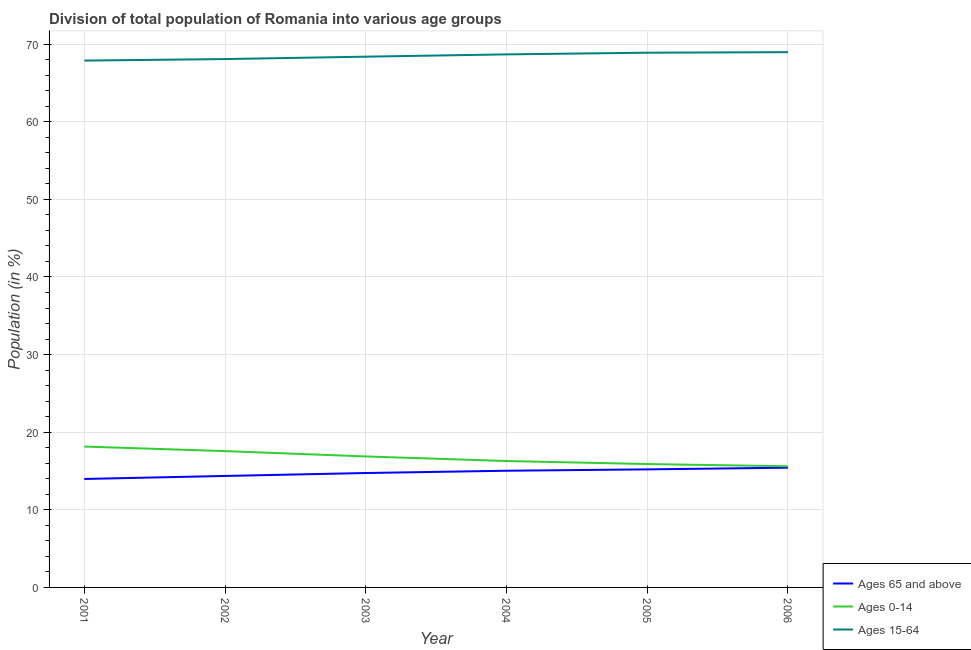Does the line corresponding to percentage of population within the age-group 15-64 intersect with the line corresponding to percentage of population within the age-group 0-14?
Provide a succinct answer. No. Is the number of lines equal to the number of legend labels?
Your answer should be compact. Yes. What is the percentage of population within the age-group of 65 and above in 2003?
Your answer should be very brief. 14.74. Across all years, what is the maximum percentage of population within the age-group 0-14?
Your answer should be compact. 18.15. Across all years, what is the minimum percentage of population within the age-group 0-14?
Your answer should be very brief. 15.61. In which year was the percentage of population within the age-group of 65 and above minimum?
Make the answer very short. 2001. What is the total percentage of population within the age-group 0-14 in the graph?
Keep it short and to the point. 100.38. What is the difference between the percentage of population within the age-group 0-14 in 2002 and that in 2006?
Ensure brevity in your answer.  1.95. What is the difference between the percentage of population within the age-group 0-14 in 2005 and the percentage of population within the age-group of 65 and above in 2001?
Keep it short and to the point. 1.92. What is the average percentage of population within the age-group 15-64 per year?
Give a very brief answer. 68.48. In the year 2003, what is the difference between the percentage of population within the age-group of 65 and above and percentage of population within the age-group 15-64?
Offer a terse response. -53.64. In how many years, is the percentage of population within the age-group 0-14 greater than 50 %?
Make the answer very short. 0. What is the ratio of the percentage of population within the age-group 15-64 in 2002 to that in 2006?
Your answer should be very brief. 0.99. Is the percentage of population within the age-group 15-64 in 2001 less than that in 2005?
Offer a terse response. Yes. What is the difference between the highest and the second highest percentage of population within the age-group of 65 and above?
Give a very brief answer. 0.22. What is the difference between the highest and the lowest percentage of population within the age-group of 65 and above?
Give a very brief answer. 1.45. Does the percentage of population within the age-group 0-14 monotonically increase over the years?
Offer a very short reply. No. Is the percentage of population within the age-group 15-64 strictly greater than the percentage of population within the age-group 0-14 over the years?
Give a very brief answer. Yes. Is the percentage of population within the age-group 0-14 strictly less than the percentage of population within the age-group of 65 and above over the years?
Your answer should be compact. No. How many years are there in the graph?
Ensure brevity in your answer.  6. Where does the legend appear in the graph?
Offer a terse response. Bottom right. How are the legend labels stacked?
Make the answer very short. Vertical. What is the title of the graph?
Keep it short and to the point. Division of total population of Romania into various age groups
. Does "Methane" appear as one of the legend labels in the graph?
Your answer should be compact. No. What is the label or title of the Y-axis?
Your answer should be very brief. Population (in %). What is the Population (in %) in Ages 65 and above in 2001?
Give a very brief answer. 13.97. What is the Population (in %) of Ages 0-14 in 2001?
Make the answer very short. 18.15. What is the Population (in %) of Ages 15-64 in 2001?
Provide a succinct answer. 67.88. What is the Population (in %) of Ages 65 and above in 2002?
Offer a very short reply. 14.36. What is the Population (in %) in Ages 0-14 in 2002?
Provide a succinct answer. 17.56. What is the Population (in %) of Ages 15-64 in 2002?
Make the answer very short. 68.07. What is the Population (in %) in Ages 65 and above in 2003?
Keep it short and to the point. 14.74. What is the Population (in %) in Ages 0-14 in 2003?
Provide a short and direct response. 16.88. What is the Population (in %) of Ages 15-64 in 2003?
Make the answer very short. 68.38. What is the Population (in %) in Ages 65 and above in 2004?
Offer a terse response. 15.03. What is the Population (in %) of Ages 0-14 in 2004?
Keep it short and to the point. 16.29. What is the Population (in %) of Ages 15-64 in 2004?
Make the answer very short. 68.68. What is the Population (in %) in Ages 65 and above in 2005?
Make the answer very short. 15.21. What is the Population (in %) of Ages 0-14 in 2005?
Provide a succinct answer. 15.9. What is the Population (in %) in Ages 15-64 in 2005?
Give a very brief answer. 68.89. What is the Population (in %) in Ages 65 and above in 2006?
Keep it short and to the point. 15.43. What is the Population (in %) in Ages 0-14 in 2006?
Your answer should be very brief. 15.61. What is the Population (in %) in Ages 15-64 in 2006?
Provide a succinct answer. 68.96. Across all years, what is the maximum Population (in %) of Ages 65 and above?
Give a very brief answer. 15.43. Across all years, what is the maximum Population (in %) of Ages 0-14?
Ensure brevity in your answer.  18.15. Across all years, what is the maximum Population (in %) of Ages 15-64?
Your answer should be compact. 68.96. Across all years, what is the minimum Population (in %) of Ages 65 and above?
Ensure brevity in your answer.  13.97. Across all years, what is the minimum Population (in %) in Ages 0-14?
Offer a terse response. 15.61. Across all years, what is the minimum Population (in %) in Ages 15-64?
Provide a short and direct response. 67.88. What is the total Population (in %) in Ages 65 and above in the graph?
Your response must be concise. 88.75. What is the total Population (in %) in Ages 0-14 in the graph?
Provide a succinct answer. 100.38. What is the total Population (in %) of Ages 15-64 in the graph?
Keep it short and to the point. 410.87. What is the difference between the Population (in %) in Ages 65 and above in 2001 and that in 2002?
Give a very brief answer. -0.39. What is the difference between the Population (in %) of Ages 0-14 in 2001 and that in 2002?
Your response must be concise. 0.59. What is the difference between the Population (in %) in Ages 15-64 in 2001 and that in 2002?
Ensure brevity in your answer.  -0.2. What is the difference between the Population (in %) of Ages 65 and above in 2001 and that in 2003?
Your response must be concise. -0.77. What is the difference between the Population (in %) in Ages 0-14 in 2001 and that in 2003?
Your response must be concise. 1.27. What is the difference between the Population (in %) in Ages 15-64 in 2001 and that in 2003?
Your answer should be compact. -0.51. What is the difference between the Population (in %) in Ages 65 and above in 2001 and that in 2004?
Give a very brief answer. -1.06. What is the difference between the Population (in %) of Ages 0-14 in 2001 and that in 2004?
Provide a short and direct response. 1.86. What is the difference between the Population (in %) in Ages 15-64 in 2001 and that in 2004?
Your answer should be compact. -0.8. What is the difference between the Population (in %) of Ages 65 and above in 2001 and that in 2005?
Your answer should be very brief. -1.24. What is the difference between the Population (in %) in Ages 0-14 in 2001 and that in 2005?
Offer a terse response. 2.25. What is the difference between the Population (in %) in Ages 15-64 in 2001 and that in 2005?
Your answer should be very brief. -1.02. What is the difference between the Population (in %) of Ages 65 and above in 2001 and that in 2006?
Offer a terse response. -1.45. What is the difference between the Population (in %) of Ages 0-14 in 2001 and that in 2006?
Ensure brevity in your answer.  2.54. What is the difference between the Population (in %) in Ages 15-64 in 2001 and that in 2006?
Keep it short and to the point. -1.09. What is the difference between the Population (in %) in Ages 65 and above in 2002 and that in 2003?
Offer a terse response. -0.38. What is the difference between the Population (in %) of Ages 0-14 in 2002 and that in 2003?
Your answer should be compact. 0.69. What is the difference between the Population (in %) of Ages 15-64 in 2002 and that in 2003?
Offer a terse response. -0.31. What is the difference between the Population (in %) of Ages 65 and above in 2002 and that in 2004?
Your answer should be very brief. -0.67. What is the difference between the Population (in %) in Ages 0-14 in 2002 and that in 2004?
Provide a succinct answer. 1.28. What is the difference between the Population (in %) of Ages 15-64 in 2002 and that in 2004?
Ensure brevity in your answer.  -0.6. What is the difference between the Population (in %) of Ages 65 and above in 2002 and that in 2005?
Offer a terse response. -0.85. What is the difference between the Population (in %) in Ages 0-14 in 2002 and that in 2005?
Offer a very short reply. 1.67. What is the difference between the Population (in %) of Ages 15-64 in 2002 and that in 2005?
Offer a very short reply. -0.82. What is the difference between the Population (in %) of Ages 65 and above in 2002 and that in 2006?
Provide a succinct answer. -1.06. What is the difference between the Population (in %) in Ages 0-14 in 2002 and that in 2006?
Offer a very short reply. 1.95. What is the difference between the Population (in %) in Ages 15-64 in 2002 and that in 2006?
Your answer should be compact. -0.89. What is the difference between the Population (in %) of Ages 65 and above in 2003 and that in 2004?
Your answer should be compact. -0.29. What is the difference between the Population (in %) in Ages 0-14 in 2003 and that in 2004?
Your response must be concise. 0.59. What is the difference between the Population (in %) in Ages 15-64 in 2003 and that in 2004?
Your answer should be very brief. -0.3. What is the difference between the Population (in %) in Ages 65 and above in 2003 and that in 2005?
Make the answer very short. -0.47. What is the difference between the Population (in %) of Ages 0-14 in 2003 and that in 2005?
Offer a very short reply. 0.98. What is the difference between the Population (in %) in Ages 15-64 in 2003 and that in 2005?
Give a very brief answer. -0.51. What is the difference between the Population (in %) in Ages 65 and above in 2003 and that in 2006?
Your answer should be very brief. -0.69. What is the difference between the Population (in %) of Ages 0-14 in 2003 and that in 2006?
Give a very brief answer. 1.27. What is the difference between the Population (in %) of Ages 15-64 in 2003 and that in 2006?
Offer a very short reply. -0.58. What is the difference between the Population (in %) in Ages 65 and above in 2004 and that in 2005?
Ensure brevity in your answer.  -0.17. What is the difference between the Population (in %) of Ages 0-14 in 2004 and that in 2005?
Your answer should be compact. 0.39. What is the difference between the Population (in %) of Ages 15-64 in 2004 and that in 2005?
Your answer should be very brief. -0.21. What is the difference between the Population (in %) of Ages 65 and above in 2004 and that in 2006?
Your answer should be very brief. -0.39. What is the difference between the Population (in %) in Ages 0-14 in 2004 and that in 2006?
Provide a short and direct response. 0.68. What is the difference between the Population (in %) in Ages 15-64 in 2004 and that in 2006?
Offer a terse response. -0.28. What is the difference between the Population (in %) of Ages 65 and above in 2005 and that in 2006?
Provide a succinct answer. -0.22. What is the difference between the Population (in %) of Ages 0-14 in 2005 and that in 2006?
Your answer should be very brief. 0.29. What is the difference between the Population (in %) in Ages 15-64 in 2005 and that in 2006?
Ensure brevity in your answer.  -0.07. What is the difference between the Population (in %) in Ages 65 and above in 2001 and the Population (in %) in Ages 0-14 in 2002?
Your response must be concise. -3.59. What is the difference between the Population (in %) in Ages 65 and above in 2001 and the Population (in %) in Ages 15-64 in 2002?
Offer a very short reply. -54.1. What is the difference between the Population (in %) in Ages 0-14 in 2001 and the Population (in %) in Ages 15-64 in 2002?
Keep it short and to the point. -49.93. What is the difference between the Population (in %) in Ages 65 and above in 2001 and the Population (in %) in Ages 0-14 in 2003?
Give a very brief answer. -2.9. What is the difference between the Population (in %) in Ages 65 and above in 2001 and the Population (in %) in Ages 15-64 in 2003?
Your response must be concise. -54.41. What is the difference between the Population (in %) in Ages 0-14 in 2001 and the Population (in %) in Ages 15-64 in 2003?
Ensure brevity in your answer.  -50.24. What is the difference between the Population (in %) in Ages 65 and above in 2001 and the Population (in %) in Ages 0-14 in 2004?
Provide a succinct answer. -2.31. What is the difference between the Population (in %) in Ages 65 and above in 2001 and the Population (in %) in Ages 15-64 in 2004?
Ensure brevity in your answer.  -54.7. What is the difference between the Population (in %) in Ages 0-14 in 2001 and the Population (in %) in Ages 15-64 in 2004?
Offer a terse response. -50.53. What is the difference between the Population (in %) in Ages 65 and above in 2001 and the Population (in %) in Ages 0-14 in 2005?
Make the answer very short. -1.92. What is the difference between the Population (in %) in Ages 65 and above in 2001 and the Population (in %) in Ages 15-64 in 2005?
Ensure brevity in your answer.  -54.92. What is the difference between the Population (in %) of Ages 0-14 in 2001 and the Population (in %) of Ages 15-64 in 2005?
Provide a succinct answer. -50.75. What is the difference between the Population (in %) of Ages 65 and above in 2001 and the Population (in %) of Ages 0-14 in 2006?
Your answer should be compact. -1.64. What is the difference between the Population (in %) of Ages 65 and above in 2001 and the Population (in %) of Ages 15-64 in 2006?
Offer a terse response. -54.99. What is the difference between the Population (in %) of Ages 0-14 in 2001 and the Population (in %) of Ages 15-64 in 2006?
Keep it short and to the point. -50.82. What is the difference between the Population (in %) in Ages 65 and above in 2002 and the Population (in %) in Ages 0-14 in 2003?
Your answer should be compact. -2.51. What is the difference between the Population (in %) in Ages 65 and above in 2002 and the Population (in %) in Ages 15-64 in 2003?
Offer a terse response. -54.02. What is the difference between the Population (in %) in Ages 0-14 in 2002 and the Population (in %) in Ages 15-64 in 2003?
Provide a short and direct response. -50.82. What is the difference between the Population (in %) in Ages 65 and above in 2002 and the Population (in %) in Ages 0-14 in 2004?
Keep it short and to the point. -1.92. What is the difference between the Population (in %) in Ages 65 and above in 2002 and the Population (in %) in Ages 15-64 in 2004?
Your response must be concise. -54.32. What is the difference between the Population (in %) of Ages 0-14 in 2002 and the Population (in %) of Ages 15-64 in 2004?
Ensure brevity in your answer.  -51.12. What is the difference between the Population (in %) of Ages 65 and above in 2002 and the Population (in %) of Ages 0-14 in 2005?
Offer a very short reply. -1.53. What is the difference between the Population (in %) in Ages 65 and above in 2002 and the Population (in %) in Ages 15-64 in 2005?
Your response must be concise. -54.53. What is the difference between the Population (in %) of Ages 0-14 in 2002 and the Population (in %) of Ages 15-64 in 2005?
Your answer should be compact. -51.33. What is the difference between the Population (in %) of Ages 65 and above in 2002 and the Population (in %) of Ages 0-14 in 2006?
Provide a short and direct response. -1.25. What is the difference between the Population (in %) in Ages 65 and above in 2002 and the Population (in %) in Ages 15-64 in 2006?
Your response must be concise. -54.6. What is the difference between the Population (in %) in Ages 0-14 in 2002 and the Population (in %) in Ages 15-64 in 2006?
Keep it short and to the point. -51.4. What is the difference between the Population (in %) of Ages 65 and above in 2003 and the Population (in %) of Ages 0-14 in 2004?
Give a very brief answer. -1.55. What is the difference between the Population (in %) of Ages 65 and above in 2003 and the Population (in %) of Ages 15-64 in 2004?
Provide a succinct answer. -53.94. What is the difference between the Population (in %) of Ages 0-14 in 2003 and the Population (in %) of Ages 15-64 in 2004?
Provide a short and direct response. -51.8. What is the difference between the Population (in %) in Ages 65 and above in 2003 and the Population (in %) in Ages 0-14 in 2005?
Offer a terse response. -1.16. What is the difference between the Population (in %) in Ages 65 and above in 2003 and the Population (in %) in Ages 15-64 in 2005?
Provide a short and direct response. -54.15. What is the difference between the Population (in %) in Ages 0-14 in 2003 and the Population (in %) in Ages 15-64 in 2005?
Keep it short and to the point. -52.02. What is the difference between the Population (in %) of Ages 65 and above in 2003 and the Population (in %) of Ages 0-14 in 2006?
Provide a short and direct response. -0.87. What is the difference between the Population (in %) of Ages 65 and above in 2003 and the Population (in %) of Ages 15-64 in 2006?
Provide a short and direct response. -54.22. What is the difference between the Population (in %) of Ages 0-14 in 2003 and the Population (in %) of Ages 15-64 in 2006?
Make the answer very short. -52.09. What is the difference between the Population (in %) in Ages 65 and above in 2004 and the Population (in %) in Ages 0-14 in 2005?
Your response must be concise. -0.86. What is the difference between the Population (in %) in Ages 65 and above in 2004 and the Population (in %) in Ages 15-64 in 2005?
Offer a very short reply. -53.86. What is the difference between the Population (in %) in Ages 0-14 in 2004 and the Population (in %) in Ages 15-64 in 2005?
Provide a succinct answer. -52.61. What is the difference between the Population (in %) of Ages 65 and above in 2004 and the Population (in %) of Ages 0-14 in 2006?
Ensure brevity in your answer.  -0.57. What is the difference between the Population (in %) of Ages 65 and above in 2004 and the Population (in %) of Ages 15-64 in 2006?
Your answer should be compact. -53.93. What is the difference between the Population (in %) of Ages 0-14 in 2004 and the Population (in %) of Ages 15-64 in 2006?
Your answer should be compact. -52.68. What is the difference between the Population (in %) in Ages 65 and above in 2005 and the Population (in %) in Ages 0-14 in 2006?
Your response must be concise. -0.4. What is the difference between the Population (in %) in Ages 65 and above in 2005 and the Population (in %) in Ages 15-64 in 2006?
Offer a terse response. -53.75. What is the difference between the Population (in %) of Ages 0-14 in 2005 and the Population (in %) of Ages 15-64 in 2006?
Keep it short and to the point. -53.07. What is the average Population (in %) in Ages 65 and above per year?
Provide a short and direct response. 14.79. What is the average Population (in %) of Ages 0-14 per year?
Your answer should be compact. 16.73. What is the average Population (in %) in Ages 15-64 per year?
Your answer should be very brief. 68.48. In the year 2001, what is the difference between the Population (in %) in Ages 65 and above and Population (in %) in Ages 0-14?
Offer a terse response. -4.17. In the year 2001, what is the difference between the Population (in %) of Ages 65 and above and Population (in %) of Ages 15-64?
Your answer should be compact. -53.9. In the year 2001, what is the difference between the Population (in %) in Ages 0-14 and Population (in %) in Ages 15-64?
Ensure brevity in your answer.  -49.73. In the year 2002, what is the difference between the Population (in %) in Ages 65 and above and Population (in %) in Ages 0-14?
Your answer should be compact. -3.2. In the year 2002, what is the difference between the Population (in %) in Ages 65 and above and Population (in %) in Ages 15-64?
Ensure brevity in your answer.  -53.71. In the year 2002, what is the difference between the Population (in %) in Ages 0-14 and Population (in %) in Ages 15-64?
Offer a very short reply. -50.51. In the year 2003, what is the difference between the Population (in %) in Ages 65 and above and Population (in %) in Ages 0-14?
Give a very brief answer. -2.14. In the year 2003, what is the difference between the Population (in %) of Ages 65 and above and Population (in %) of Ages 15-64?
Make the answer very short. -53.64. In the year 2003, what is the difference between the Population (in %) in Ages 0-14 and Population (in %) in Ages 15-64?
Keep it short and to the point. -51.51. In the year 2004, what is the difference between the Population (in %) in Ages 65 and above and Population (in %) in Ages 0-14?
Your response must be concise. -1.25. In the year 2004, what is the difference between the Population (in %) of Ages 65 and above and Population (in %) of Ages 15-64?
Provide a short and direct response. -53.64. In the year 2004, what is the difference between the Population (in %) of Ages 0-14 and Population (in %) of Ages 15-64?
Offer a terse response. -52.39. In the year 2005, what is the difference between the Population (in %) of Ages 65 and above and Population (in %) of Ages 0-14?
Offer a very short reply. -0.69. In the year 2005, what is the difference between the Population (in %) of Ages 65 and above and Population (in %) of Ages 15-64?
Make the answer very short. -53.68. In the year 2005, what is the difference between the Population (in %) of Ages 0-14 and Population (in %) of Ages 15-64?
Provide a short and direct response. -53. In the year 2006, what is the difference between the Population (in %) of Ages 65 and above and Population (in %) of Ages 0-14?
Ensure brevity in your answer.  -0.18. In the year 2006, what is the difference between the Population (in %) in Ages 65 and above and Population (in %) in Ages 15-64?
Give a very brief answer. -53.54. In the year 2006, what is the difference between the Population (in %) of Ages 0-14 and Population (in %) of Ages 15-64?
Your answer should be compact. -53.35. What is the ratio of the Population (in %) of Ages 65 and above in 2001 to that in 2002?
Make the answer very short. 0.97. What is the ratio of the Population (in %) of Ages 65 and above in 2001 to that in 2003?
Ensure brevity in your answer.  0.95. What is the ratio of the Population (in %) in Ages 0-14 in 2001 to that in 2003?
Your answer should be very brief. 1.08. What is the ratio of the Population (in %) of Ages 15-64 in 2001 to that in 2003?
Your response must be concise. 0.99. What is the ratio of the Population (in %) in Ages 65 and above in 2001 to that in 2004?
Give a very brief answer. 0.93. What is the ratio of the Population (in %) of Ages 0-14 in 2001 to that in 2004?
Offer a very short reply. 1.11. What is the ratio of the Population (in %) in Ages 15-64 in 2001 to that in 2004?
Your answer should be very brief. 0.99. What is the ratio of the Population (in %) of Ages 65 and above in 2001 to that in 2005?
Keep it short and to the point. 0.92. What is the ratio of the Population (in %) in Ages 0-14 in 2001 to that in 2005?
Your answer should be very brief. 1.14. What is the ratio of the Population (in %) of Ages 65 and above in 2001 to that in 2006?
Keep it short and to the point. 0.91. What is the ratio of the Population (in %) in Ages 0-14 in 2001 to that in 2006?
Offer a terse response. 1.16. What is the ratio of the Population (in %) in Ages 15-64 in 2001 to that in 2006?
Provide a succinct answer. 0.98. What is the ratio of the Population (in %) of Ages 65 and above in 2002 to that in 2003?
Your answer should be very brief. 0.97. What is the ratio of the Population (in %) of Ages 0-14 in 2002 to that in 2003?
Offer a terse response. 1.04. What is the ratio of the Population (in %) of Ages 15-64 in 2002 to that in 2003?
Keep it short and to the point. 1. What is the ratio of the Population (in %) of Ages 65 and above in 2002 to that in 2004?
Keep it short and to the point. 0.96. What is the ratio of the Population (in %) in Ages 0-14 in 2002 to that in 2004?
Make the answer very short. 1.08. What is the ratio of the Population (in %) in Ages 65 and above in 2002 to that in 2005?
Your answer should be very brief. 0.94. What is the ratio of the Population (in %) of Ages 0-14 in 2002 to that in 2005?
Provide a short and direct response. 1.1. What is the ratio of the Population (in %) of Ages 15-64 in 2002 to that in 2005?
Give a very brief answer. 0.99. What is the ratio of the Population (in %) of Ages 0-14 in 2002 to that in 2006?
Keep it short and to the point. 1.13. What is the ratio of the Population (in %) in Ages 15-64 in 2002 to that in 2006?
Provide a succinct answer. 0.99. What is the ratio of the Population (in %) in Ages 65 and above in 2003 to that in 2004?
Offer a terse response. 0.98. What is the ratio of the Population (in %) in Ages 0-14 in 2003 to that in 2004?
Offer a terse response. 1.04. What is the ratio of the Population (in %) of Ages 65 and above in 2003 to that in 2005?
Keep it short and to the point. 0.97. What is the ratio of the Population (in %) in Ages 0-14 in 2003 to that in 2005?
Provide a short and direct response. 1.06. What is the ratio of the Population (in %) in Ages 65 and above in 2003 to that in 2006?
Keep it short and to the point. 0.96. What is the ratio of the Population (in %) of Ages 0-14 in 2003 to that in 2006?
Offer a very short reply. 1.08. What is the ratio of the Population (in %) in Ages 65 and above in 2004 to that in 2005?
Provide a short and direct response. 0.99. What is the ratio of the Population (in %) of Ages 0-14 in 2004 to that in 2005?
Give a very brief answer. 1.02. What is the ratio of the Population (in %) of Ages 65 and above in 2004 to that in 2006?
Provide a succinct answer. 0.97. What is the ratio of the Population (in %) in Ages 0-14 in 2004 to that in 2006?
Offer a very short reply. 1.04. What is the ratio of the Population (in %) of Ages 65 and above in 2005 to that in 2006?
Keep it short and to the point. 0.99. What is the ratio of the Population (in %) of Ages 0-14 in 2005 to that in 2006?
Your response must be concise. 1.02. What is the ratio of the Population (in %) of Ages 15-64 in 2005 to that in 2006?
Provide a succinct answer. 1. What is the difference between the highest and the second highest Population (in %) of Ages 65 and above?
Provide a short and direct response. 0.22. What is the difference between the highest and the second highest Population (in %) of Ages 0-14?
Offer a terse response. 0.59. What is the difference between the highest and the second highest Population (in %) of Ages 15-64?
Give a very brief answer. 0.07. What is the difference between the highest and the lowest Population (in %) of Ages 65 and above?
Provide a succinct answer. 1.45. What is the difference between the highest and the lowest Population (in %) in Ages 0-14?
Provide a succinct answer. 2.54. What is the difference between the highest and the lowest Population (in %) of Ages 15-64?
Make the answer very short. 1.09. 